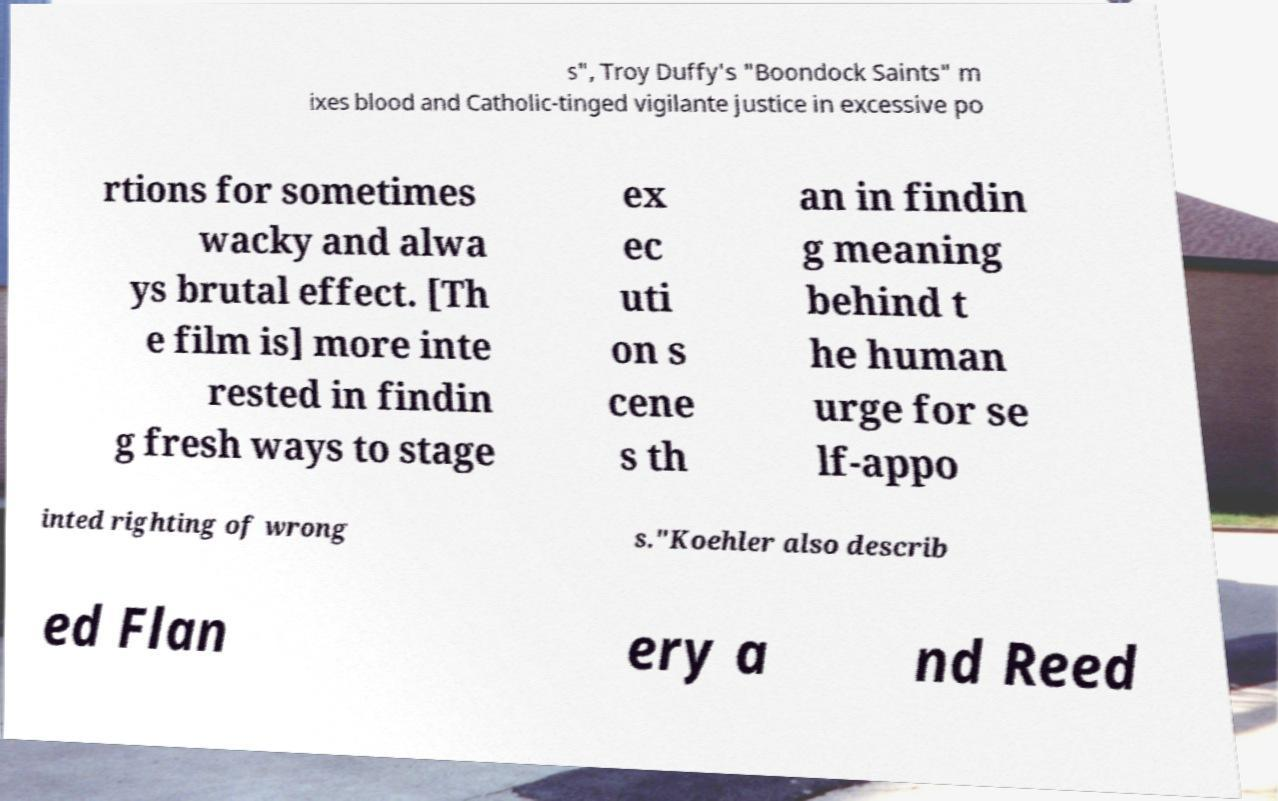Please identify and transcribe the text found in this image. s", Troy Duffy's "Boondock Saints" m ixes blood and Catholic-tinged vigilante justice in excessive po rtions for sometimes wacky and alwa ys brutal effect. [Th e film is] more inte rested in findin g fresh ways to stage ex ec uti on s cene s th an in findin g meaning behind t he human urge for se lf-appo inted righting of wrong s."Koehler also describ ed Flan ery a nd Reed 